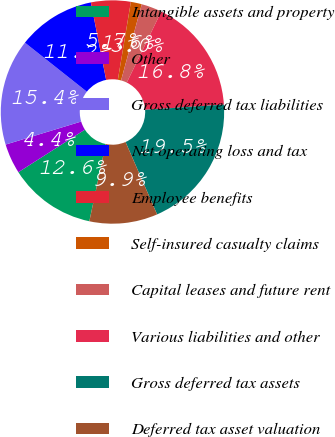Convert chart to OTSL. <chart><loc_0><loc_0><loc_500><loc_500><pie_chart><fcel>Intangible assets and property<fcel>Other<fcel>Gross deferred tax liabilities<fcel>Net operating loss and tax<fcel>Employee benefits<fcel>Self-insured casualty claims<fcel>Capital leases and future rent<fcel>Various liabilities and other<fcel>Gross deferred tax assets<fcel>Deferred tax asset valuation<nl><fcel>12.62%<fcel>4.35%<fcel>15.37%<fcel>11.24%<fcel>5.73%<fcel>1.59%<fcel>2.97%<fcel>16.75%<fcel>19.51%<fcel>9.86%<nl></chart> 